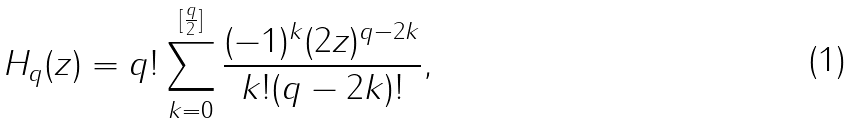Convert formula to latex. <formula><loc_0><loc_0><loc_500><loc_500>H _ { q } ( z ) = q ! \sum _ { k = 0 } ^ { [ \frac { q } { 2 } ] } \frac { ( - 1 ) ^ { k } ( 2 z ) ^ { q - 2 k } } { k ! ( q - 2 k ) ! } ,</formula> 